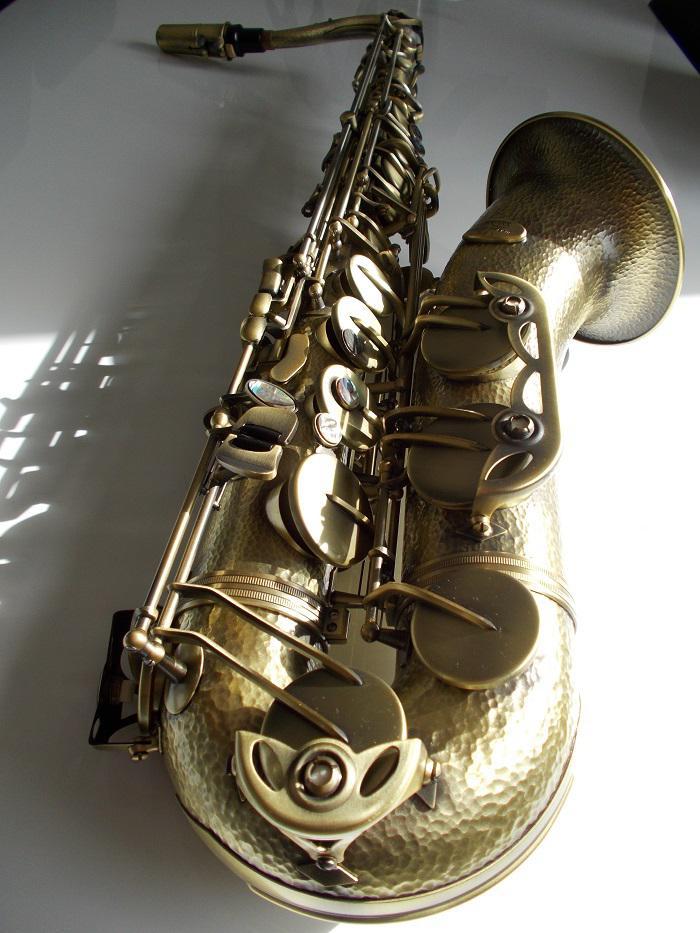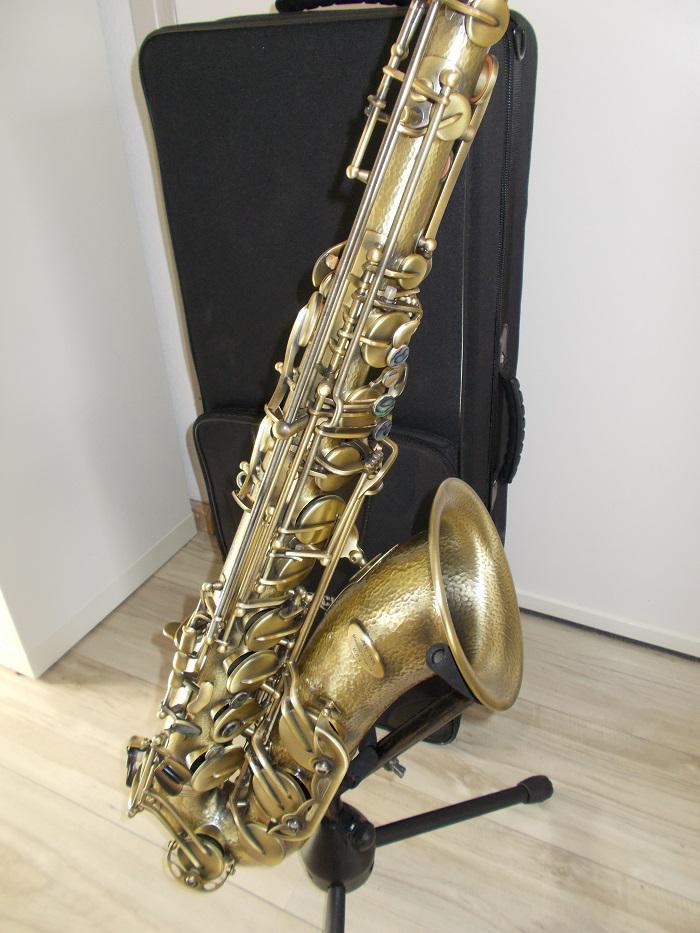The first image is the image on the left, the second image is the image on the right. For the images shown, is this caption "In at least on image there is a brass saxophone facing left with it black case behind it." true? Answer yes or no. Yes. 